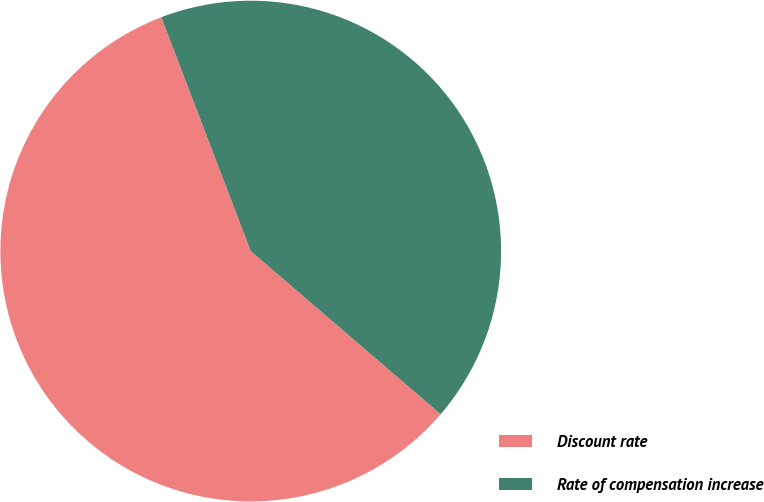<chart> <loc_0><loc_0><loc_500><loc_500><pie_chart><fcel>Discount rate<fcel>Rate of compensation increase<nl><fcel>57.89%<fcel>42.11%<nl></chart> 